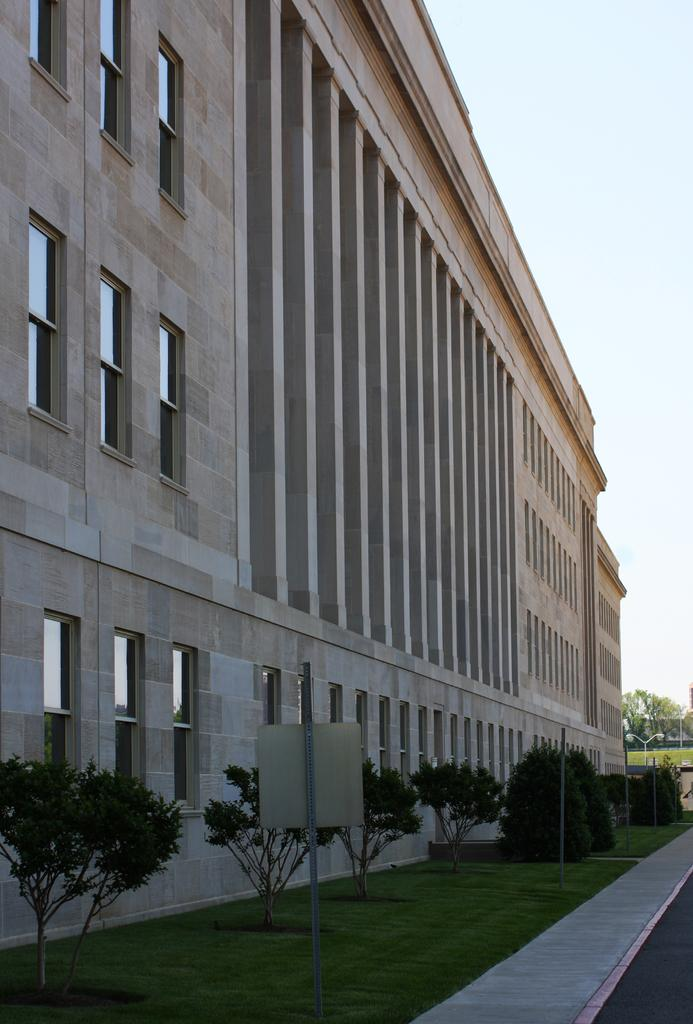What type of structure is visible in the image? There is a building in the image. What feature can be seen on the building? The building has windows. What type of vegetation is present in the image? There are plants, grass, and trees in the image. What object can be seen in the image that is not part of the building or vegetation? There is a board in the image. What flavor of waste can be seen in the image? There is no waste present in the image, and therefore no flavor can be determined. 